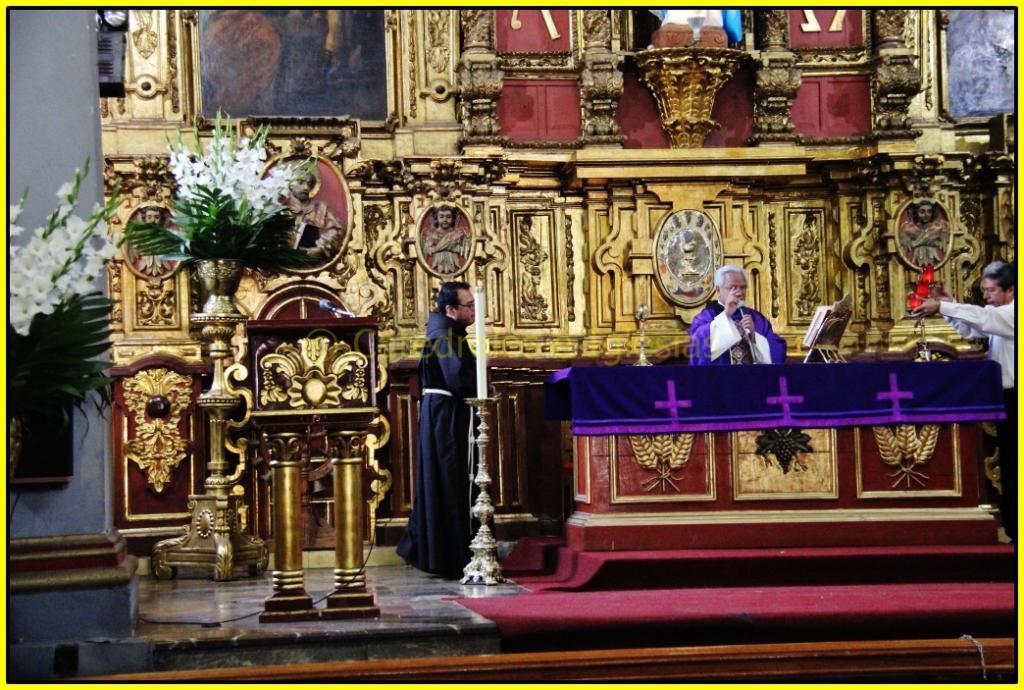How would you summarize this image in a sentence or two? In the center of the image we can see three persons are standing and they are holding some objects. In front of them, there is a table. On the table, we can see one book stand, book, cloth and a few other objects. At the bottom of the image we can see one red carpet. In the background there is a wall, photo frames, poles, one candle, vases, plants, flowers, and a few other objects. And we can see some design on the wall and on the table. 